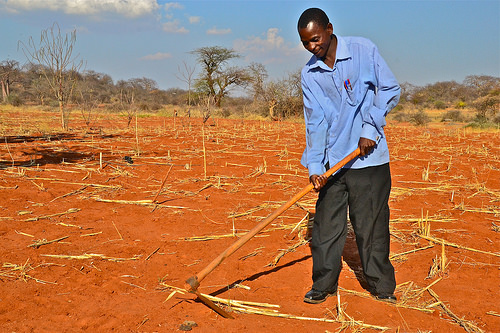<image>
Is there a stick on the ground? Yes. Looking at the image, I can see the stick is positioned on top of the ground, with the ground providing support. 